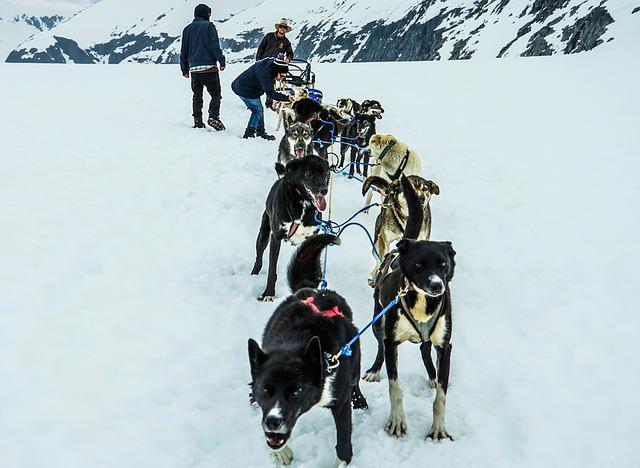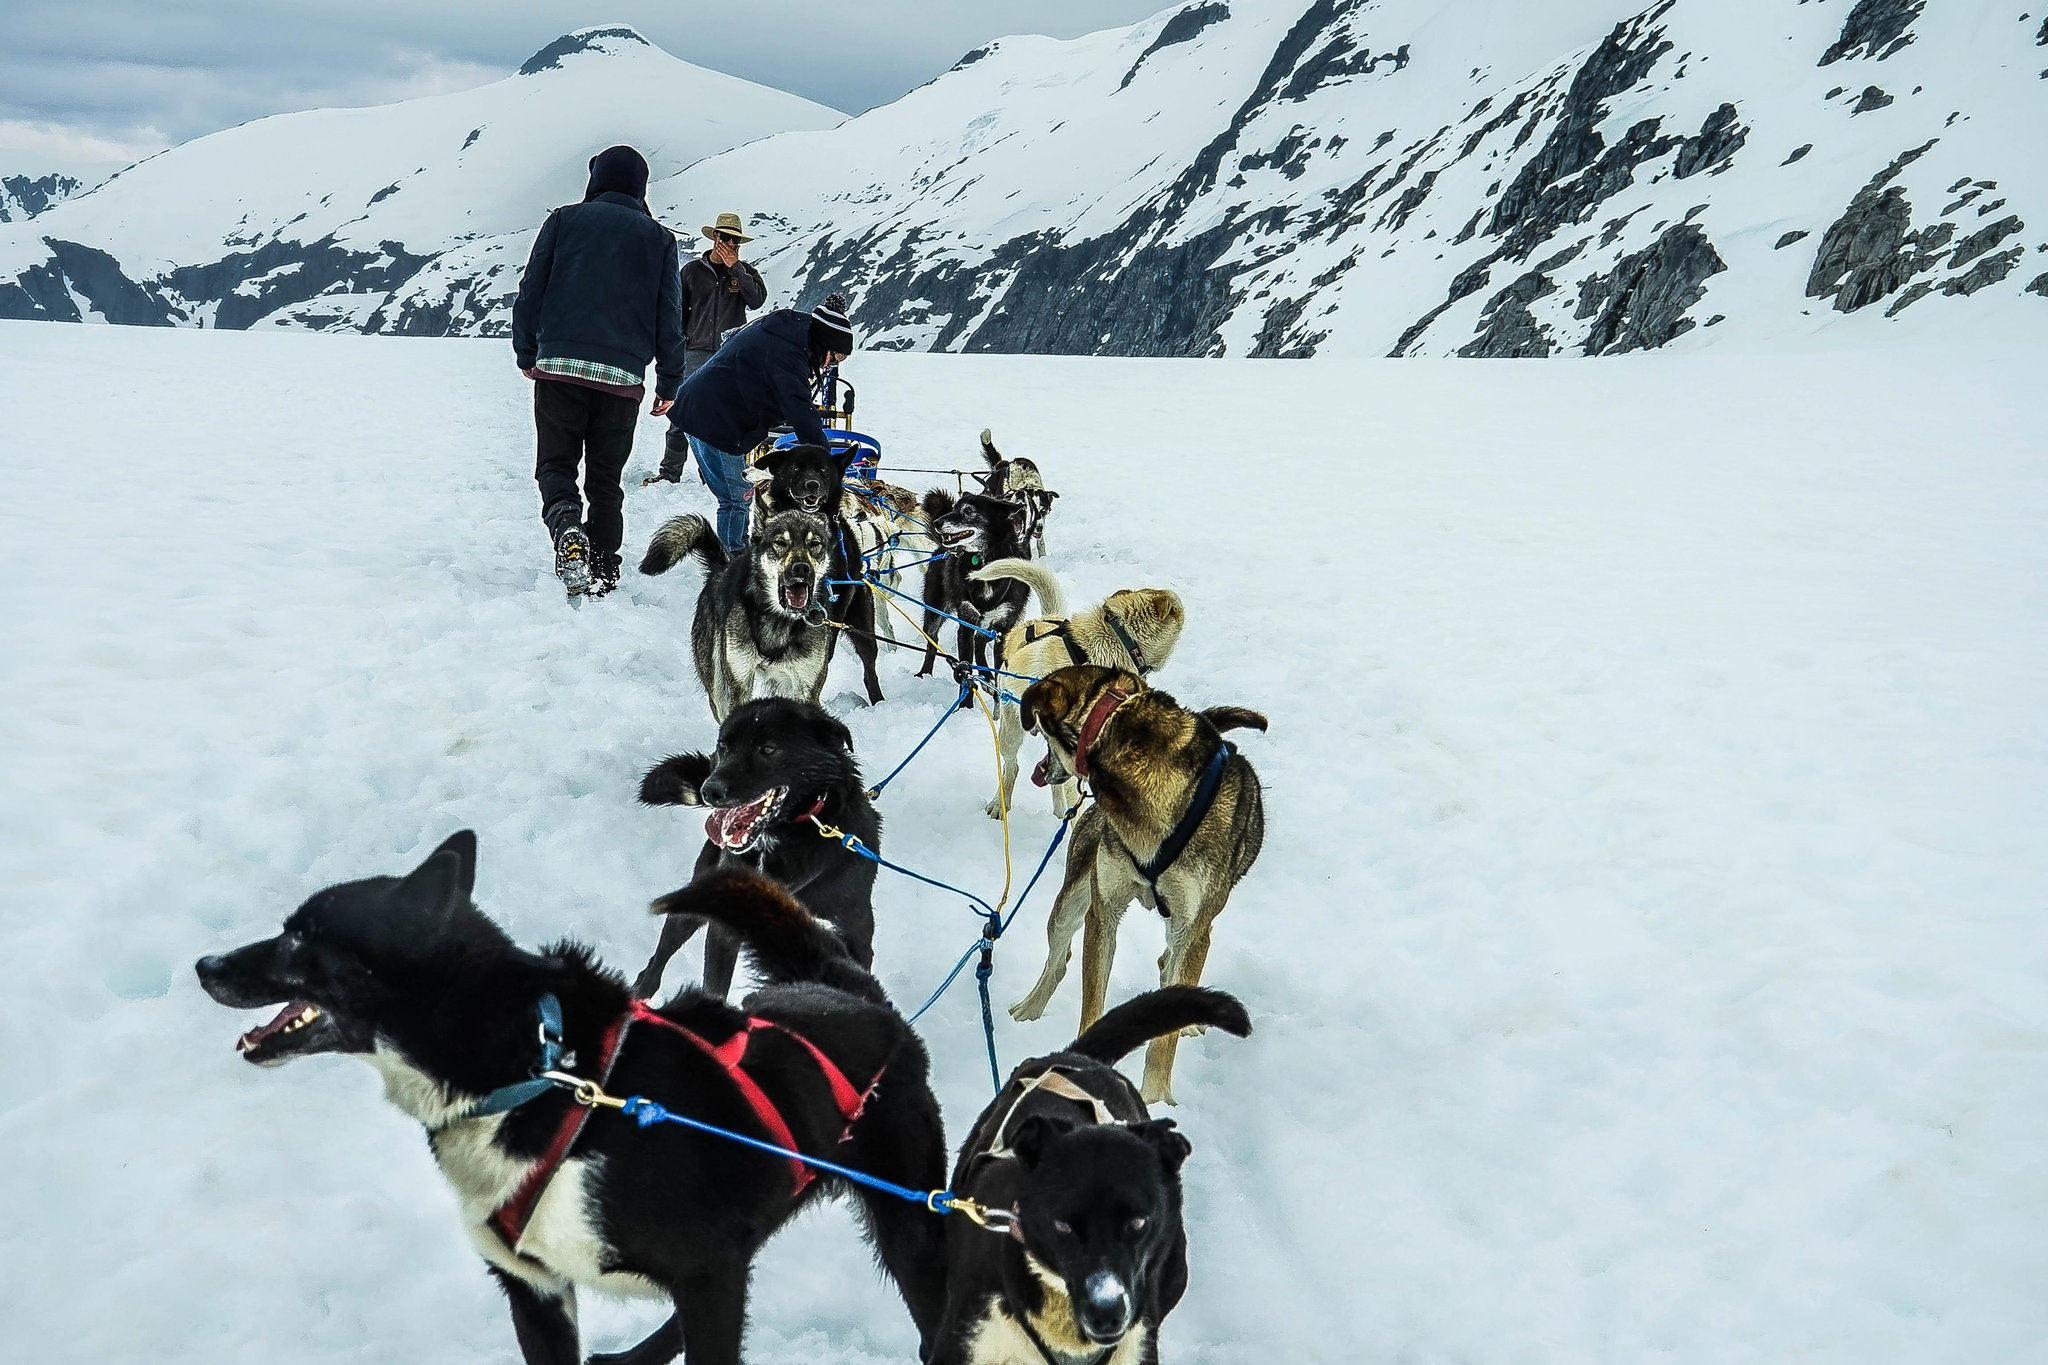The first image is the image on the left, the second image is the image on the right. For the images shown, is this caption "There is a person with a red coat in one of the images." true? Answer yes or no. No. 